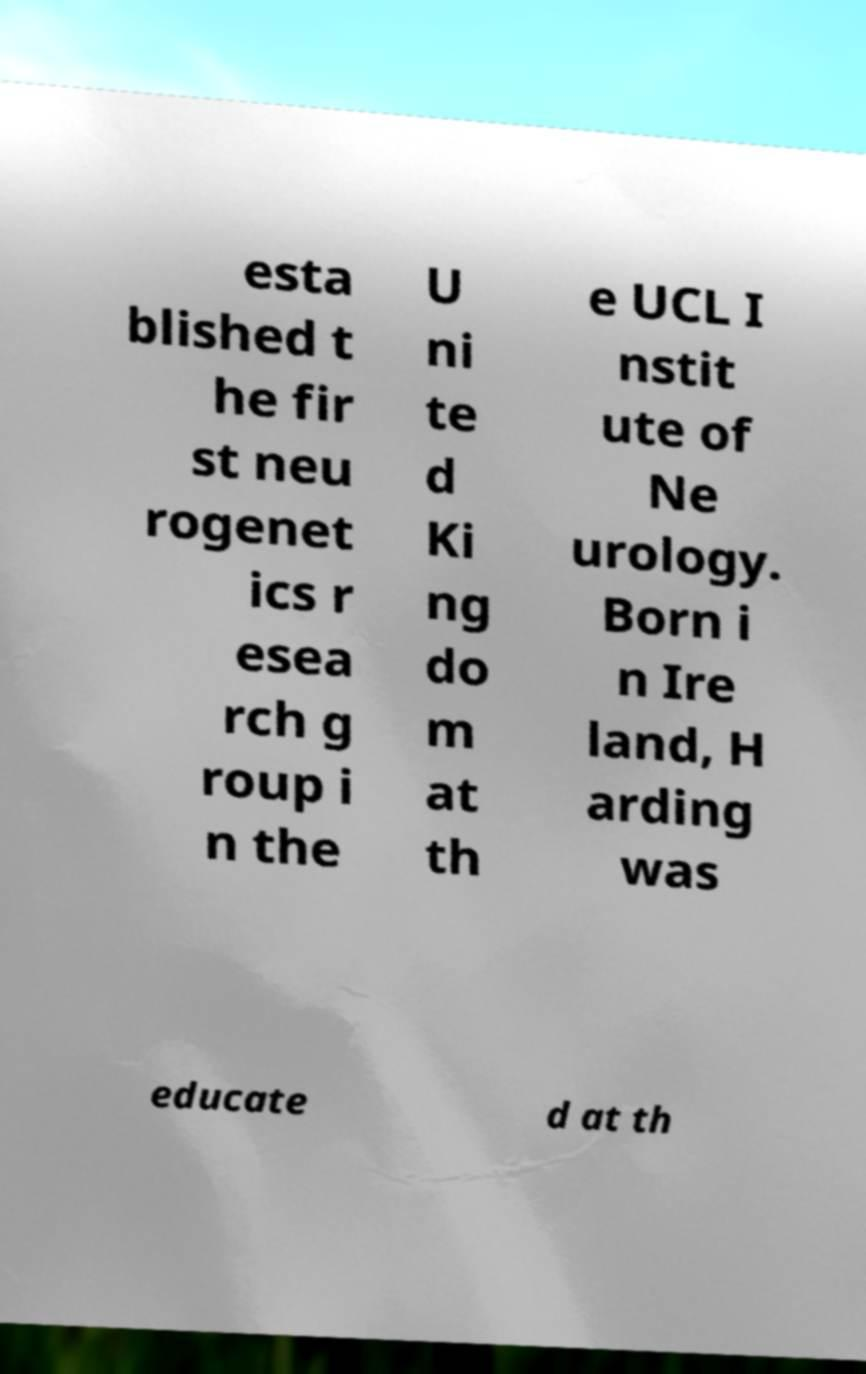I need the written content from this picture converted into text. Can you do that? esta blished t he fir st neu rogenet ics r esea rch g roup i n the U ni te d Ki ng do m at th e UCL I nstit ute of Ne urology. Born i n Ire land, H arding was educate d at th 